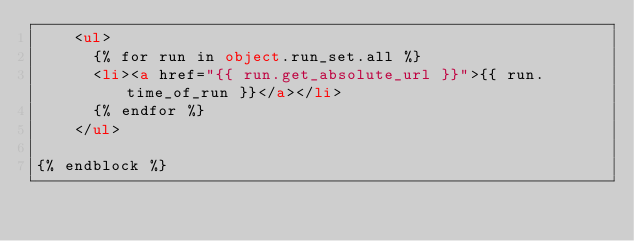Convert code to text. <code><loc_0><loc_0><loc_500><loc_500><_HTML_>    <ul>
      {% for run in object.run_set.all %}
      <li><a href="{{ run.get_absolute_url }}">{{ run.time_of_run }}</a></li>
      {% endfor %}
    </ul>

{% endblock %}
</code> 